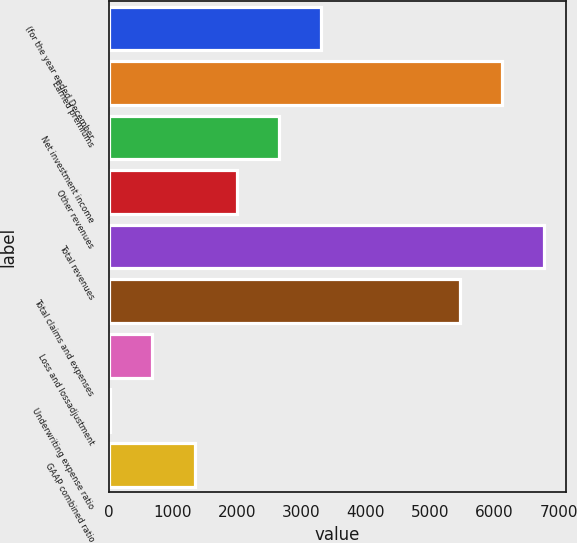Convert chart to OTSL. <chart><loc_0><loc_0><loc_500><loc_500><bar_chart><fcel>(for the year ended December<fcel>Earned premiums<fcel>Net investment income<fcel>Other revenues<fcel>Total revenues<fcel>Total claims and expenses<fcel>Loss and lossadjustment<fcel>Underwriting expense ratio<fcel>GAAP combined ratio<nl><fcel>3303.95<fcel>6119.41<fcel>2648.54<fcel>1993.13<fcel>6774.82<fcel>5464<fcel>682.31<fcel>26.9<fcel>1337.72<nl></chart> 